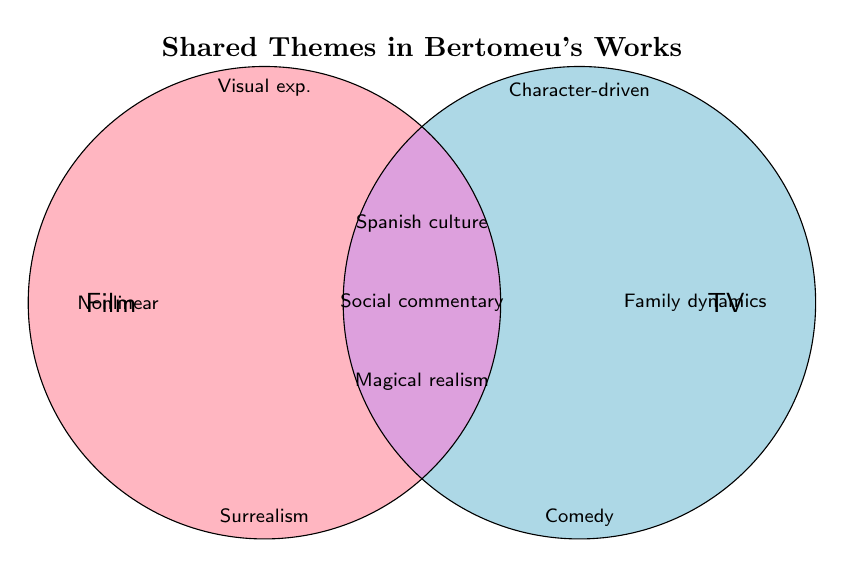What's the title of the Venn diagram? The title is displayed at the top of the Venn diagram with bold font
Answer: Shared Themes in Bertomeu's Works How many themes are unique to his film projects? The unique themes for films are listed in the left circle, which are three themes
Answer: 3 What are the themes that are common between both film and TV works? The themes common to both film and TV works are in the overlapping area of the Venn diagram
Answer: Spanish culture, Social commentary, Magical realism Which theme only appears in his TV projects and not in films? The unique themes for TV projects are within the right circle area not overlapping with the left, such as Comedy, Character-driven plots, and Family dynamics
Answer: Comedy, Character-driven plots, Family dynamics How many themes are unique to either films or TV but not both? Counting the themes unique to films (3) and TV (3)
Answer: 6 Which themes are associated with psychological and family dynamics? The theme related to psychological studies is in the film section, and family dynamics in the TV section
Answer: Psychological themes (Film), Family dynamics (TV) Does nonlinear narratives appear in his TV projects? It is only noted in the film section
Answer: No How many more themes are in the shared area compared to unique themes in films or TV? Compare the number of themes in the overlap (3) with the unique ones (3 in film, 3 in TV). Number of themes in the shared area matches the unique themes
Answer: 0 more themes Are historical settings exclusive to one type of project? Historical settings appear only within the film circle
Answer: Yes, exclusive to film What type of thematic settings are found in his TV projects? The settings in his TV projects include Modern-day stories as per the elements within the right circle
Answer: Modern-day stories 